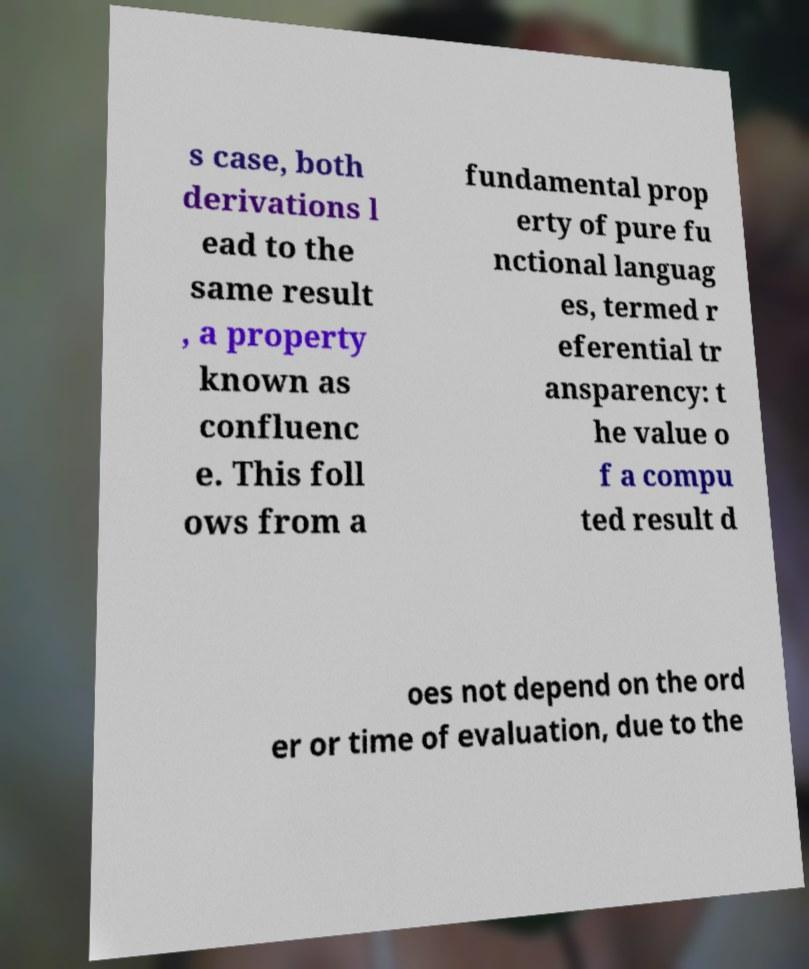Can you accurately transcribe the text from the provided image for me? s case, both derivations l ead to the same result , a property known as confluenc e. This foll ows from a fundamental prop erty of pure fu nctional languag es, termed r eferential tr ansparency: t he value o f a compu ted result d oes not depend on the ord er or time of evaluation, due to the 